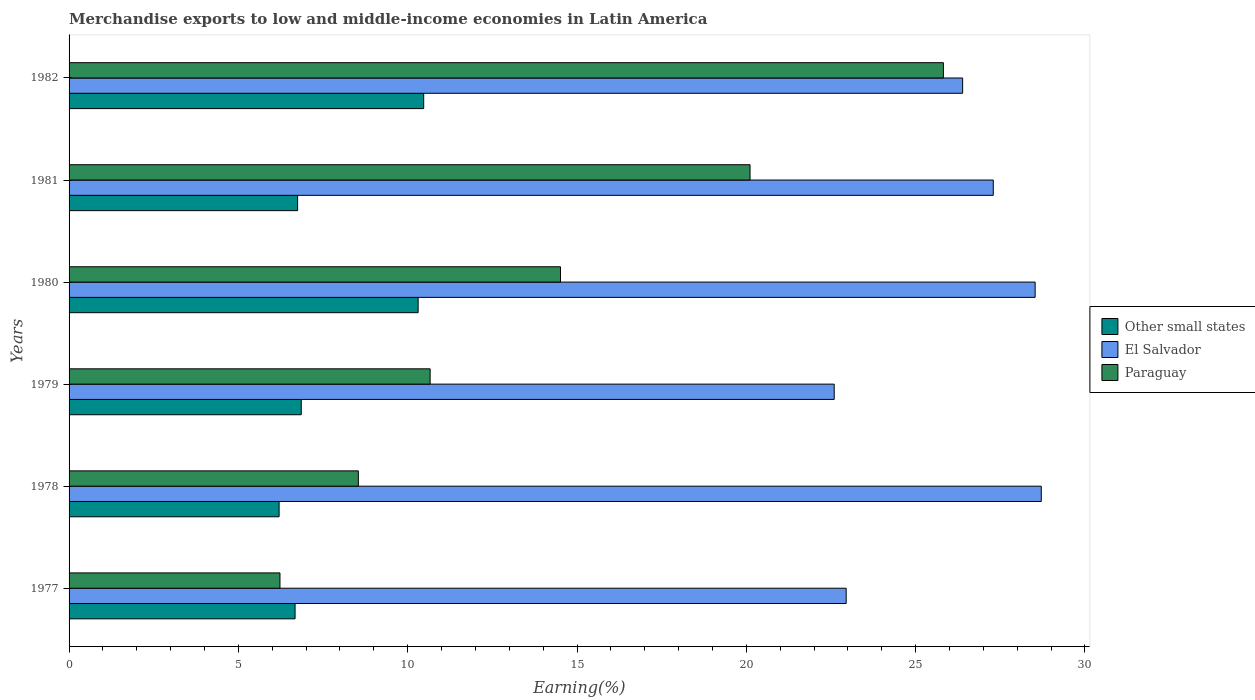How many different coloured bars are there?
Make the answer very short. 3. How many groups of bars are there?
Your answer should be compact. 6. How many bars are there on the 2nd tick from the top?
Your answer should be compact. 3. What is the label of the 5th group of bars from the top?
Give a very brief answer. 1978. In how many cases, is the number of bars for a given year not equal to the number of legend labels?
Provide a succinct answer. 0. What is the percentage of amount earned from merchandise exports in El Salvador in 1977?
Your answer should be compact. 22.95. Across all years, what is the maximum percentage of amount earned from merchandise exports in Other small states?
Keep it short and to the point. 10.47. Across all years, what is the minimum percentage of amount earned from merchandise exports in Other small states?
Offer a very short reply. 6.2. In which year was the percentage of amount earned from merchandise exports in El Salvador minimum?
Your response must be concise. 1979. What is the total percentage of amount earned from merchandise exports in Paraguay in the graph?
Ensure brevity in your answer.  85.87. What is the difference between the percentage of amount earned from merchandise exports in Paraguay in 1977 and that in 1978?
Provide a short and direct response. -2.31. What is the difference between the percentage of amount earned from merchandise exports in Other small states in 1979 and the percentage of amount earned from merchandise exports in Paraguay in 1980?
Your response must be concise. -7.66. What is the average percentage of amount earned from merchandise exports in Other small states per year?
Your answer should be compact. 7.88. In the year 1978, what is the difference between the percentage of amount earned from merchandise exports in Paraguay and percentage of amount earned from merchandise exports in Other small states?
Make the answer very short. 2.34. In how many years, is the percentage of amount earned from merchandise exports in El Salvador greater than 19 %?
Give a very brief answer. 6. What is the ratio of the percentage of amount earned from merchandise exports in El Salvador in 1977 to that in 1978?
Provide a succinct answer. 0.8. Is the percentage of amount earned from merchandise exports in Other small states in 1979 less than that in 1981?
Your answer should be very brief. No. What is the difference between the highest and the second highest percentage of amount earned from merchandise exports in El Salvador?
Offer a terse response. 0.18. What is the difference between the highest and the lowest percentage of amount earned from merchandise exports in Paraguay?
Keep it short and to the point. 19.59. Is the sum of the percentage of amount earned from merchandise exports in Paraguay in 1978 and 1980 greater than the maximum percentage of amount earned from merchandise exports in El Salvador across all years?
Your answer should be very brief. No. What does the 1st bar from the top in 1981 represents?
Your response must be concise. Paraguay. What does the 1st bar from the bottom in 1980 represents?
Keep it short and to the point. Other small states. How many bars are there?
Ensure brevity in your answer.  18. Are all the bars in the graph horizontal?
Your answer should be very brief. Yes. How many years are there in the graph?
Give a very brief answer. 6. What is the difference between two consecutive major ticks on the X-axis?
Your answer should be compact. 5. Are the values on the major ticks of X-axis written in scientific E-notation?
Make the answer very short. No. Does the graph contain any zero values?
Offer a very short reply. No. Does the graph contain grids?
Offer a terse response. No. How are the legend labels stacked?
Your answer should be compact. Vertical. What is the title of the graph?
Your answer should be compact. Merchandise exports to low and middle-income economies in Latin America. What is the label or title of the X-axis?
Keep it short and to the point. Earning(%). What is the Earning(%) in Other small states in 1977?
Give a very brief answer. 6.67. What is the Earning(%) in El Salvador in 1977?
Ensure brevity in your answer.  22.95. What is the Earning(%) in Paraguay in 1977?
Your answer should be compact. 6.23. What is the Earning(%) of Other small states in 1978?
Provide a succinct answer. 6.2. What is the Earning(%) in El Salvador in 1978?
Your answer should be very brief. 28.71. What is the Earning(%) in Paraguay in 1978?
Provide a succinct answer. 8.54. What is the Earning(%) in Other small states in 1979?
Give a very brief answer. 6.86. What is the Earning(%) in El Salvador in 1979?
Make the answer very short. 22.59. What is the Earning(%) in Paraguay in 1979?
Your response must be concise. 10.66. What is the Earning(%) of Other small states in 1980?
Make the answer very short. 10.31. What is the Earning(%) in El Salvador in 1980?
Your answer should be compact. 28.53. What is the Earning(%) in Paraguay in 1980?
Offer a very short reply. 14.51. What is the Earning(%) in Other small states in 1981?
Offer a very short reply. 6.75. What is the Earning(%) of El Salvador in 1981?
Your response must be concise. 27.29. What is the Earning(%) of Paraguay in 1981?
Provide a succinct answer. 20.11. What is the Earning(%) in Other small states in 1982?
Offer a very short reply. 10.47. What is the Earning(%) of El Salvador in 1982?
Offer a terse response. 26.39. What is the Earning(%) in Paraguay in 1982?
Your response must be concise. 25.82. Across all years, what is the maximum Earning(%) in Other small states?
Your response must be concise. 10.47. Across all years, what is the maximum Earning(%) of El Salvador?
Provide a short and direct response. 28.71. Across all years, what is the maximum Earning(%) in Paraguay?
Offer a very short reply. 25.82. Across all years, what is the minimum Earning(%) in Other small states?
Make the answer very short. 6.2. Across all years, what is the minimum Earning(%) in El Salvador?
Your response must be concise. 22.59. Across all years, what is the minimum Earning(%) of Paraguay?
Your response must be concise. 6.23. What is the total Earning(%) in Other small states in the graph?
Your answer should be compact. 47.26. What is the total Earning(%) in El Salvador in the graph?
Your answer should be compact. 156.46. What is the total Earning(%) of Paraguay in the graph?
Offer a terse response. 85.87. What is the difference between the Earning(%) of Other small states in 1977 and that in 1978?
Keep it short and to the point. 0.47. What is the difference between the Earning(%) of El Salvador in 1977 and that in 1978?
Make the answer very short. -5.76. What is the difference between the Earning(%) of Paraguay in 1977 and that in 1978?
Make the answer very short. -2.31. What is the difference between the Earning(%) in Other small states in 1977 and that in 1979?
Make the answer very short. -0.18. What is the difference between the Earning(%) in El Salvador in 1977 and that in 1979?
Keep it short and to the point. 0.35. What is the difference between the Earning(%) in Paraguay in 1977 and that in 1979?
Your response must be concise. -4.43. What is the difference between the Earning(%) of Other small states in 1977 and that in 1980?
Give a very brief answer. -3.63. What is the difference between the Earning(%) in El Salvador in 1977 and that in 1980?
Provide a short and direct response. -5.58. What is the difference between the Earning(%) in Paraguay in 1977 and that in 1980?
Offer a terse response. -8.28. What is the difference between the Earning(%) in Other small states in 1977 and that in 1981?
Offer a very short reply. -0.08. What is the difference between the Earning(%) in El Salvador in 1977 and that in 1981?
Keep it short and to the point. -4.34. What is the difference between the Earning(%) in Paraguay in 1977 and that in 1981?
Your answer should be compact. -13.88. What is the difference between the Earning(%) of Other small states in 1977 and that in 1982?
Make the answer very short. -3.8. What is the difference between the Earning(%) of El Salvador in 1977 and that in 1982?
Your answer should be compact. -3.44. What is the difference between the Earning(%) in Paraguay in 1977 and that in 1982?
Make the answer very short. -19.59. What is the difference between the Earning(%) in Other small states in 1978 and that in 1979?
Make the answer very short. -0.65. What is the difference between the Earning(%) in El Salvador in 1978 and that in 1979?
Your answer should be very brief. 6.12. What is the difference between the Earning(%) of Paraguay in 1978 and that in 1979?
Offer a terse response. -2.12. What is the difference between the Earning(%) of Other small states in 1978 and that in 1980?
Your answer should be very brief. -4.11. What is the difference between the Earning(%) in El Salvador in 1978 and that in 1980?
Provide a succinct answer. 0.18. What is the difference between the Earning(%) in Paraguay in 1978 and that in 1980?
Provide a short and direct response. -5.97. What is the difference between the Earning(%) in Other small states in 1978 and that in 1981?
Offer a terse response. -0.55. What is the difference between the Earning(%) of El Salvador in 1978 and that in 1981?
Offer a very short reply. 1.42. What is the difference between the Earning(%) of Paraguay in 1978 and that in 1981?
Keep it short and to the point. -11.57. What is the difference between the Earning(%) in Other small states in 1978 and that in 1982?
Keep it short and to the point. -4.27. What is the difference between the Earning(%) in El Salvador in 1978 and that in 1982?
Make the answer very short. 2.32. What is the difference between the Earning(%) in Paraguay in 1978 and that in 1982?
Give a very brief answer. -17.28. What is the difference between the Earning(%) of Other small states in 1979 and that in 1980?
Provide a succinct answer. -3.45. What is the difference between the Earning(%) of El Salvador in 1979 and that in 1980?
Your answer should be compact. -5.93. What is the difference between the Earning(%) in Paraguay in 1979 and that in 1980?
Your response must be concise. -3.85. What is the difference between the Earning(%) in Other small states in 1979 and that in 1981?
Your answer should be very brief. 0.11. What is the difference between the Earning(%) of El Salvador in 1979 and that in 1981?
Provide a short and direct response. -4.7. What is the difference between the Earning(%) in Paraguay in 1979 and that in 1981?
Make the answer very short. -9.45. What is the difference between the Earning(%) in Other small states in 1979 and that in 1982?
Keep it short and to the point. -3.62. What is the difference between the Earning(%) in El Salvador in 1979 and that in 1982?
Your answer should be very brief. -3.79. What is the difference between the Earning(%) of Paraguay in 1979 and that in 1982?
Your answer should be compact. -15.16. What is the difference between the Earning(%) of Other small states in 1980 and that in 1981?
Your answer should be very brief. 3.56. What is the difference between the Earning(%) of El Salvador in 1980 and that in 1981?
Offer a very short reply. 1.24. What is the difference between the Earning(%) of Paraguay in 1980 and that in 1981?
Ensure brevity in your answer.  -5.6. What is the difference between the Earning(%) in Other small states in 1980 and that in 1982?
Make the answer very short. -0.16. What is the difference between the Earning(%) in El Salvador in 1980 and that in 1982?
Your answer should be very brief. 2.14. What is the difference between the Earning(%) in Paraguay in 1980 and that in 1982?
Make the answer very short. -11.31. What is the difference between the Earning(%) in Other small states in 1981 and that in 1982?
Your answer should be compact. -3.72. What is the difference between the Earning(%) of El Salvador in 1981 and that in 1982?
Your answer should be very brief. 0.9. What is the difference between the Earning(%) in Paraguay in 1981 and that in 1982?
Your response must be concise. -5.71. What is the difference between the Earning(%) in Other small states in 1977 and the Earning(%) in El Salvador in 1978?
Keep it short and to the point. -22.04. What is the difference between the Earning(%) of Other small states in 1977 and the Earning(%) of Paraguay in 1978?
Offer a terse response. -1.87. What is the difference between the Earning(%) in El Salvador in 1977 and the Earning(%) in Paraguay in 1978?
Provide a short and direct response. 14.41. What is the difference between the Earning(%) in Other small states in 1977 and the Earning(%) in El Salvador in 1979?
Give a very brief answer. -15.92. What is the difference between the Earning(%) of Other small states in 1977 and the Earning(%) of Paraguay in 1979?
Offer a terse response. -3.99. What is the difference between the Earning(%) in El Salvador in 1977 and the Earning(%) in Paraguay in 1979?
Offer a very short reply. 12.29. What is the difference between the Earning(%) of Other small states in 1977 and the Earning(%) of El Salvador in 1980?
Provide a short and direct response. -21.85. What is the difference between the Earning(%) of Other small states in 1977 and the Earning(%) of Paraguay in 1980?
Offer a very short reply. -7.84. What is the difference between the Earning(%) in El Salvador in 1977 and the Earning(%) in Paraguay in 1980?
Your response must be concise. 8.44. What is the difference between the Earning(%) in Other small states in 1977 and the Earning(%) in El Salvador in 1981?
Provide a succinct answer. -20.62. What is the difference between the Earning(%) in Other small states in 1977 and the Earning(%) in Paraguay in 1981?
Provide a short and direct response. -13.44. What is the difference between the Earning(%) in El Salvador in 1977 and the Earning(%) in Paraguay in 1981?
Your answer should be very brief. 2.84. What is the difference between the Earning(%) in Other small states in 1977 and the Earning(%) in El Salvador in 1982?
Offer a terse response. -19.71. What is the difference between the Earning(%) in Other small states in 1977 and the Earning(%) in Paraguay in 1982?
Your answer should be very brief. -19.14. What is the difference between the Earning(%) in El Salvador in 1977 and the Earning(%) in Paraguay in 1982?
Ensure brevity in your answer.  -2.87. What is the difference between the Earning(%) in Other small states in 1978 and the Earning(%) in El Salvador in 1979?
Provide a short and direct response. -16.39. What is the difference between the Earning(%) of Other small states in 1978 and the Earning(%) of Paraguay in 1979?
Offer a very short reply. -4.46. What is the difference between the Earning(%) in El Salvador in 1978 and the Earning(%) in Paraguay in 1979?
Your response must be concise. 18.05. What is the difference between the Earning(%) of Other small states in 1978 and the Earning(%) of El Salvador in 1980?
Ensure brevity in your answer.  -22.33. What is the difference between the Earning(%) in Other small states in 1978 and the Earning(%) in Paraguay in 1980?
Provide a short and direct response. -8.31. What is the difference between the Earning(%) of El Salvador in 1978 and the Earning(%) of Paraguay in 1980?
Give a very brief answer. 14.2. What is the difference between the Earning(%) in Other small states in 1978 and the Earning(%) in El Salvador in 1981?
Provide a succinct answer. -21.09. What is the difference between the Earning(%) in Other small states in 1978 and the Earning(%) in Paraguay in 1981?
Give a very brief answer. -13.91. What is the difference between the Earning(%) in El Salvador in 1978 and the Earning(%) in Paraguay in 1981?
Ensure brevity in your answer.  8.6. What is the difference between the Earning(%) in Other small states in 1978 and the Earning(%) in El Salvador in 1982?
Provide a succinct answer. -20.18. What is the difference between the Earning(%) of Other small states in 1978 and the Earning(%) of Paraguay in 1982?
Ensure brevity in your answer.  -19.62. What is the difference between the Earning(%) of El Salvador in 1978 and the Earning(%) of Paraguay in 1982?
Your response must be concise. 2.89. What is the difference between the Earning(%) in Other small states in 1979 and the Earning(%) in El Salvador in 1980?
Provide a short and direct response. -21.67. What is the difference between the Earning(%) of Other small states in 1979 and the Earning(%) of Paraguay in 1980?
Your answer should be very brief. -7.66. What is the difference between the Earning(%) in El Salvador in 1979 and the Earning(%) in Paraguay in 1980?
Offer a very short reply. 8.08. What is the difference between the Earning(%) of Other small states in 1979 and the Earning(%) of El Salvador in 1981?
Provide a short and direct response. -20.44. What is the difference between the Earning(%) in Other small states in 1979 and the Earning(%) in Paraguay in 1981?
Your answer should be compact. -13.25. What is the difference between the Earning(%) of El Salvador in 1979 and the Earning(%) of Paraguay in 1981?
Your answer should be very brief. 2.49. What is the difference between the Earning(%) in Other small states in 1979 and the Earning(%) in El Salvador in 1982?
Ensure brevity in your answer.  -19.53. What is the difference between the Earning(%) in Other small states in 1979 and the Earning(%) in Paraguay in 1982?
Your answer should be very brief. -18.96. What is the difference between the Earning(%) of El Salvador in 1979 and the Earning(%) of Paraguay in 1982?
Make the answer very short. -3.22. What is the difference between the Earning(%) of Other small states in 1980 and the Earning(%) of El Salvador in 1981?
Ensure brevity in your answer.  -16.98. What is the difference between the Earning(%) of Other small states in 1980 and the Earning(%) of Paraguay in 1981?
Offer a very short reply. -9.8. What is the difference between the Earning(%) in El Salvador in 1980 and the Earning(%) in Paraguay in 1981?
Your response must be concise. 8.42. What is the difference between the Earning(%) in Other small states in 1980 and the Earning(%) in El Salvador in 1982?
Make the answer very short. -16.08. What is the difference between the Earning(%) in Other small states in 1980 and the Earning(%) in Paraguay in 1982?
Make the answer very short. -15.51. What is the difference between the Earning(%) in El Salvador in 1980 and the Earning(%) in Paraguay in 1982?
Ensure brevity in your answer.  2.71. What is the difference between the Earning(%) in Other small states in 1981 and the Earning(%) in El Salvador in 1982?
Your response must be concise. -19.64. What is the difference between the Earning(%) of Other small states in 1981 and the Earning(%) of Paraguay in 1982?
Your response must be concise. -19.07. What is the difference between the Earning(%) in El Salvador in 1981 and the Earning(%) in Paraguay in 1982?
Offer a terse response. 1.47. What is the average Earning(%) in Other small states per year?
Give a very brief answer. 7.88. What is the average Earning(%) of El Salvador per year?
Keep it short and to the point. 26.08. What is the average Earning(%) of Paraguay per year?
Your answer should be very brief. 14.31. In the year 1977, what is the difference between the Earning(%) of Other small states and Earning(%) of El Salvador?
Give a very brief answer. -16.27. In the year 1977, what is the difference between the Earning(%) in Other small states and Earning(%) in Paraguay?
Make the answer very short. 0.45. In the year 1977, what is the difference between the Earning(%) in El Salvador and Earning(%) in Paraguay?
Your answer should be compact. 16.72. In the year 1978, what is the difference between the Earning(%) of Other small states and Earning(%) of El Salvador?
Keep it short and to the point. -22.51. In the year 1978, what is the difference between the Earning(%) of Other small states and Earning(%) of Paraguay?
Your response must be concise. -2.34. In the year 1978, what is the difference between the Earning(%) of El Salvador and Earning(%) of Paraguay?
Your response must be concise. 20.17. In the year 1979, what is the difference between the Earning(%) in Other small states and Earning(%) in El Salvador?
Offer a very short reply. -15.74. In the year 1979, what is the difference between the Earning(%) in Other small states and Earning(%) in Paraguay?
Provide a short and direct response. -3.81. In the year 1979, what is the difference between the Earning(%) of El Salvador and Earning(%) of Paraguay?
Provide a short and direct response. 11.93. In the year 1980, what is the difference between the Earning(%) in Other small states and Earning(%) in El Salvador?
Your response must be concise. -18.22. In the year 1980, what is the difference between the Earning(%) in Other small states and Earning(%) in Paraguay?
Provide a short and direct response. -4.2. In the year 1980, what is the difference between the Earning(%) in El Salvador and Earning(%) in Paraguay?
Your answer should be compact. 14.02. In the year 1981, what is the difference between the Earning(%) of Other small states and Earning(%) of El Salvador?
Your answer should be very brief. -20.54. In the year 1981, what is the difference between the Earning(%) in Other small states and Earning(%) in Paraguay?
Give a very brief answer. -13.36. In the year 1981, what is the difference between the Earning(%) of El Salvador and Earning(%) of Paraguay?
Provide a succinct answer. 7.18. In the year 1982, what is the difference between the Earning(%) in Other small states and Earning(%) in El Salvador?
Your response must be concise. -15.91. In the year 1982, what is the difference between the Earning(%) of Other small states and Earning(%) of Paraguay?
Ensure brevity in your answer.  -15.35. In the year 1982, what is the difference between the Earning(%) in El Salvador and Earning(%) in Paraguay?
Provide a succinct answer. 0.57. What is the ratio of the Earning(%) in Other small states in 1977 to that in 1978?
Make the answer very short. 1.08. What is the ratio of the Earning(%) in El Salvador in 1977 to that in 1978?
Provide a succinct answer. 0.8. What is the ratio of the Earning(%) of Paraguay in 1977 to that in 1978?
Your answer should be compact. 0.73. What is the ratio of the Earning(%) in Other small states in 1977 to that in 1979?
Provide a succinct answer. 0.97. What is the ratio of the Earning(%) in El Salvador in 1977 to that in 1979?
Offer a terse response. 1.02. What is the ratio of the Earning(%) of Paraguay in 1977 to that in 1979?
Give a very brief answer. 0.58. What is the ratio of the Earning(%) of Other small states in 1977 to that in 1980?
Provide a succinct answer. 0.65. What is the ratio of the Earning(%) in El Salvador in 1977 to that in 1980?
Make the answer very short. 0.8. What is the ratio of the Earning(%) of Paraguay in 1977 to that in 1980?
Offer a very short reply. 0.43. What is the ratio of the Earning(%) of El Salvador in 1977 to that in 1981?
Your response must be concise. 0.84. What is the ratio of the Earning(%) of Paraguay in 1977 to that in 1981?
Ensure brevity in your answer.  0.31. What is the ratio of the Earning(%) of Other small states in 1977 to that in 1982?
Give a very brief answer. 0.64. What is the ratio of the Earning(%) of El Salvador in 1977 to that in 1982?
Your response must be concise. 0.87. What is the ratio of the Earning(%) of Paraguay in 1977 to that in 1982?
Keep it short and to the point. 0.24. What is the ratio of the Earning(%) in Other small states in 1978 to that in 1979?
Your response must be concise. 0.9. What is the ratio of the Earning(%) of El Salvador in 1978 to that in 1979?
Offer a terse response. 1.27. What is the ratio of the Earning(%) in Paraguay in 1978 to that in 1979?
Offer a very short reply. 0.8. What is the ratio of the Earning(%) of Other small states in 1978 to that in 1980?
Keep it short and to the point. 0.6. What is the ratio of the Earning(%) of El Salvador in 1978 to that in 1980?
Give a very brief answer. 1.01. What is the ratio of the Earning(%) of Paraguay in 1978 to that in 1980?
Make the answer very short. 0.59. What is the ratio of the Earning(%) of Other small states in 1978 to that in 1981?
Offer a very short reply. 0.92. What is the ratio of the Earning(%) in El Salvador in 1978 to that in 1981?
Offer a very short reply. 1.05. What is the ratio of the Earning(%) of Paraguay in 1978 to that in 1981?
Offer a very short reply. 0.42. What is the ratio of the Earning(%) of Other small states in 1978 to that in 1982?
Offer a terse response. 0.59. What is the ratio of the Earning(%) in El Salvador in 1978 to that in 1982?
Give a very brief answer. 1.09. What is the ratio of the Earning(%) in Paraguay in 1978 to that in 1982?
Your answer should be compact. 0.33. What is the ratio of the Earning(%) in Other small states in 1979 to that in 1980?
Offer a terse response. 0.67. What is the ratio of the Earning(%) of El Salvador in 1979 to that in 1980?
Provide a succinct answer. 0.79. What is the ratio of the Earning(%) of Paraguay in 1979 to that in 1980?
Offer a very short reply. 0.73. What is the ratio of the Earning(%) in Other small states in 1979 to that in 1981?
Provide a short and direct response. 1.02. What is the ratio of the Earning(%) in El Salvador in 1979 to that in 1981?
Offer a very short reply. 0.83. What is the ratio of the Earning(%) of Paraguay in 1979 to that in 1981?
Your response must be concise. 0.53. What is the ratio of the Earning(%) in Other small states in 1979 to that in 1982?
Make the answer very short. 0.65. What is the ratio of the Earning(%) in El Salvador in 1979 to that in 1982?
Your response must be concise. 0.86. What is the ratio of the Earning(%) of Paraguay in 1979 to that in 1982?
Offer a terse response. 0.41. What is the ratio of the Earning(%) of Other small states in 1980 to that in 1981?
Ensure brevity in your answer.  1.53. What is the ratio of the Earning(%) of El Salvador in 1980 to that in 1981?
Keep it short and to the point. 1.05. What is the ratio of the Earning(%) in Paraguay in 1980 to that in 1981?
Provide a succinct answer. 0.72. What is the ratio of the Earning(%) of Other small states in 1980 to that in 1982?
Your answer should be compact. 0.98. What is the ratio of the Earning(%) in El Salvador in 1980 to that in 1982?
Offer a very short reply. 1.08. What is the ratio of the Earning(%) of Paraguay in 1980 to that in 1982?
Your answer should be compact. 0.56. What is the ratio of the Earning(%) in Other small states in 1981 to that in 1982?
Offer a very short reply. 0.64. What is the ratio of the Earning(%) in El Salvador in 1981 to that in 1982?
Your response must be concise. 1.03. What is the ratio of the Earning(%) of Paraguay in 1981 to that in 1982?
Your answer should be compact. 0.78. What is the difference between the highest and the second highest Earning(%) of Other small states?
Keep it short and to the point. 0.16. What is the difference between the highest and the second highest Earning(%) in El Salvador?
Your response must be concise. 0.18. What is the difference between the highest and the second highest Earning(%) of Paraguay?
Give a very brief answer. 5.71. What is the difference between the highest and the lowest Earning(%) of Other small states?
Provide a short and direct response. 4.27. What is the difference between the highest and the lowest Earning(%) of El Salvador?
Give a very brief answer. 6.12. What is the difference between the highest and the lowest Earning(%) in Paraguay?
Give a very brief answer. 19.59. 